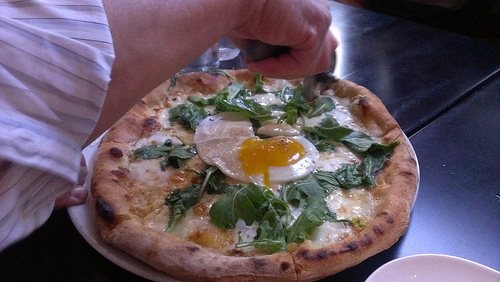What vegetable is to the left of the cheese? The vegetable to the left of the cheese is spinach. 